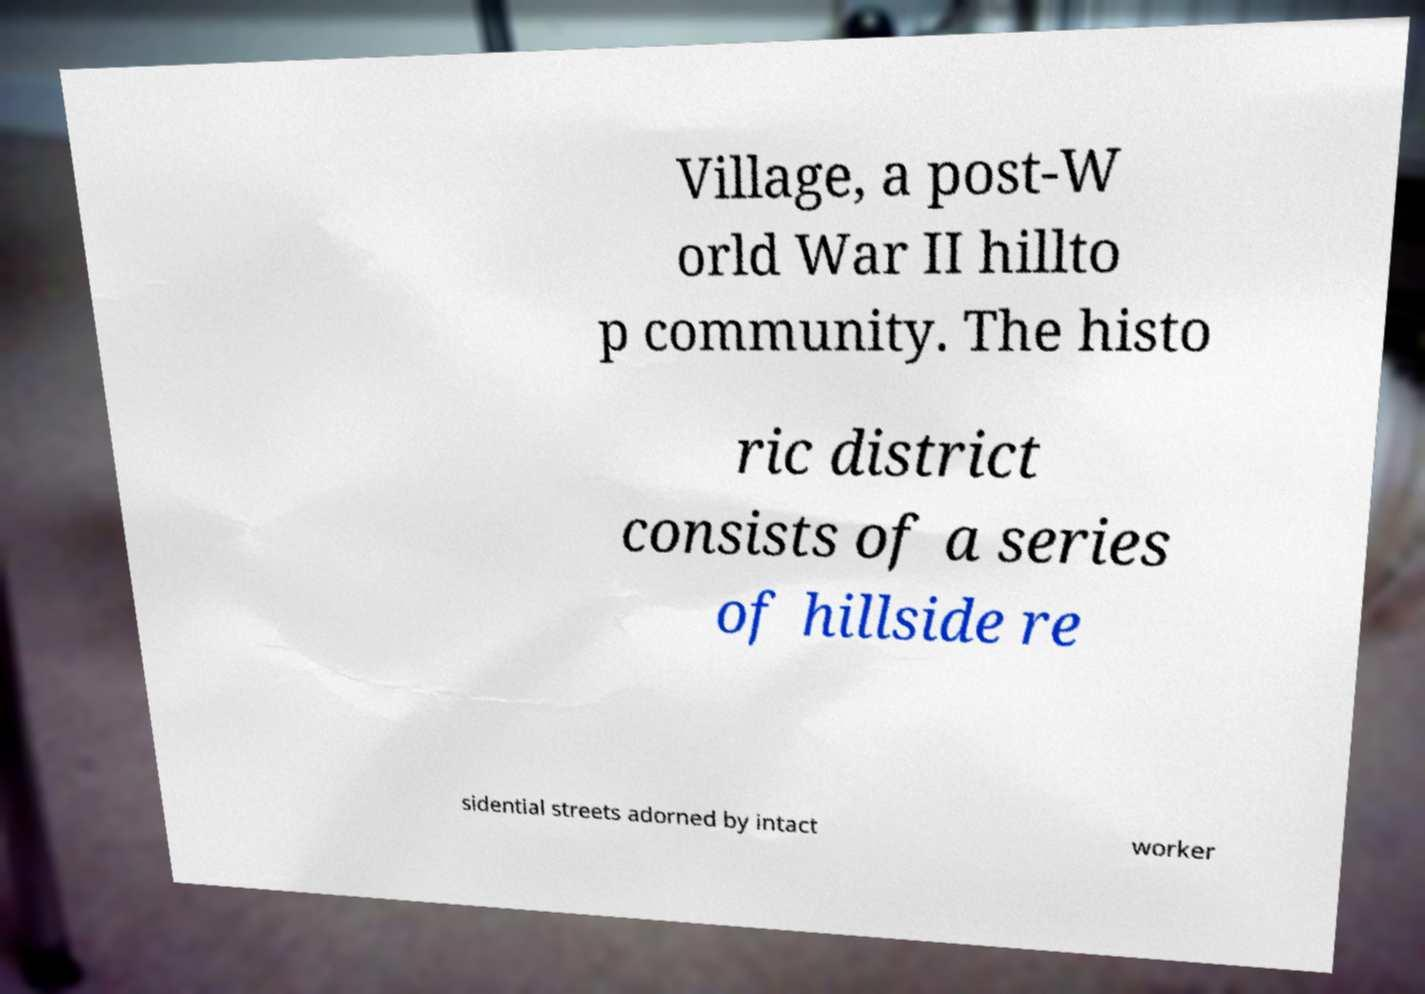Please read and relay the text visible in this image. What does it say? Village, a post-W orld War II hillto p community. The histo ric district consists of a series of hillside re sidential streets adorned by intact worker 